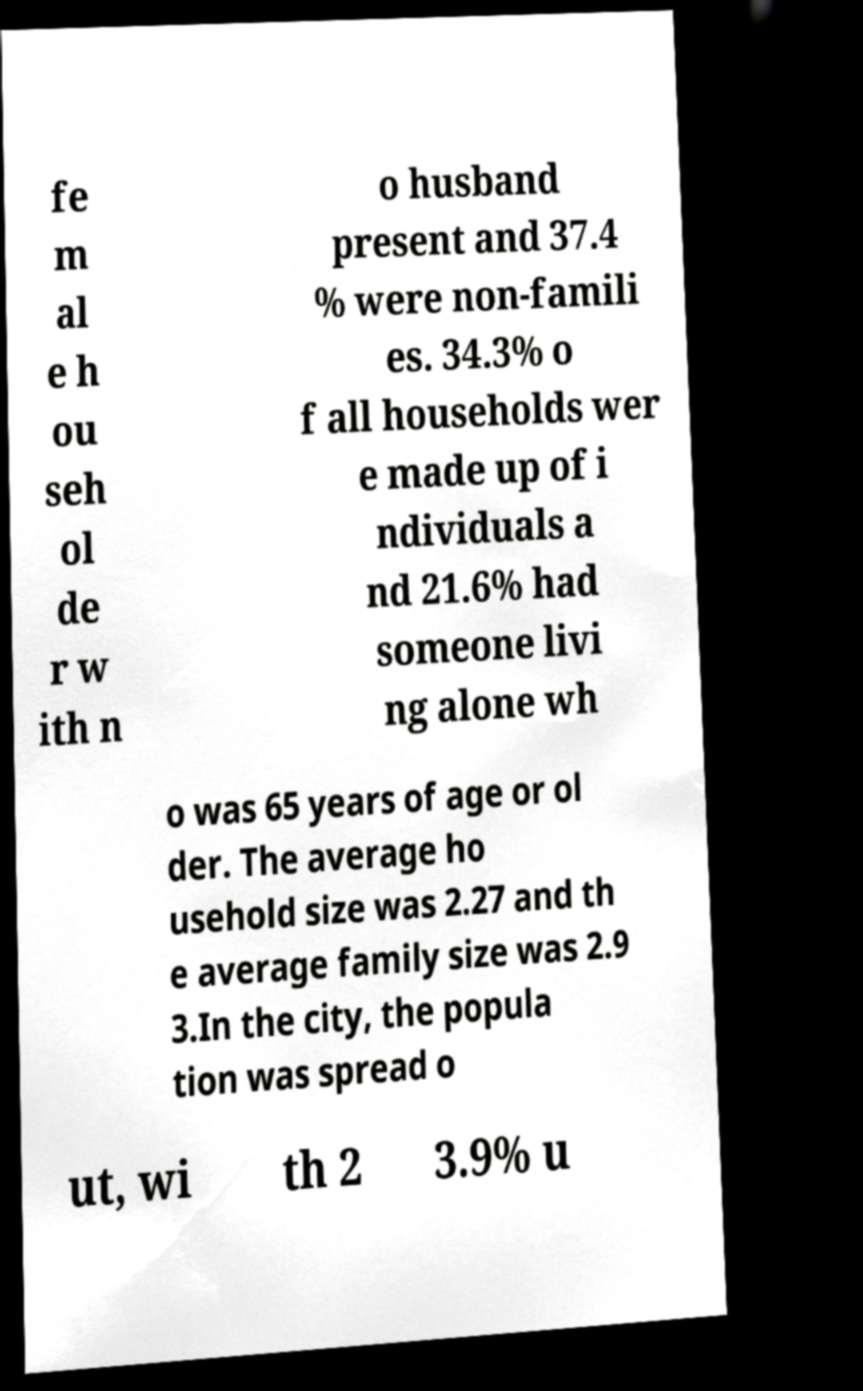Can you accurately transcribe the text from the provided image for me? fe m al e h ou seh ol de r w ith n o husband present and 37.4 % were non-famili es. 34.3% o f all households wer e made up of i ndividuals a nd 21.6% had someone livi ng alone wh o was 65 years of age or ol der. The average ho usehold size was 2.27 and th e average family size was 2.9 3.In the city, the popula tion was spread o ut, wi th 2 3.9% u 